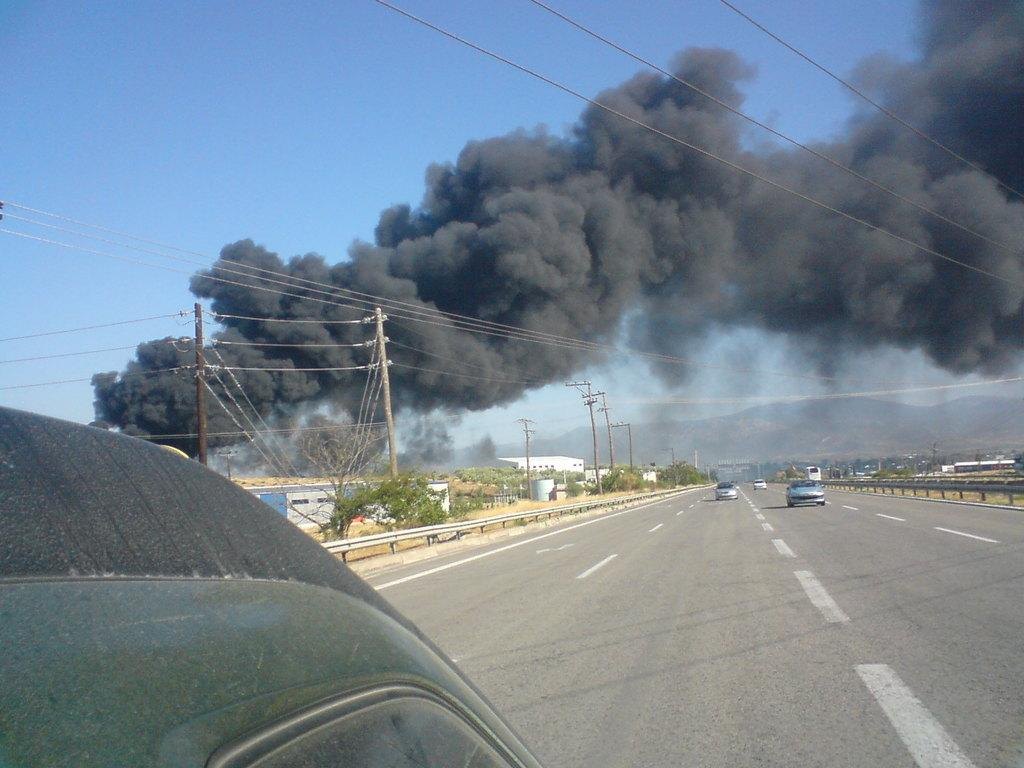What can be seen on the road in the image? There are vehicles on the road in the image. What type of vegetation is present on either side of the road? There are trees on either side of the road in the image. What type of structures are present on either side of the road? There are buildings on either side of the road in the image. What else can be seen in the image besides the road, trees, and buildings? There are poles and wires in the image. What is visible in the left corner of the image? There is smoke visible in the left corner of the image. What type of wall can be seen in the image? There is no wall present in the image. What type of cub is visible in the image? There is no cub present in the image. 